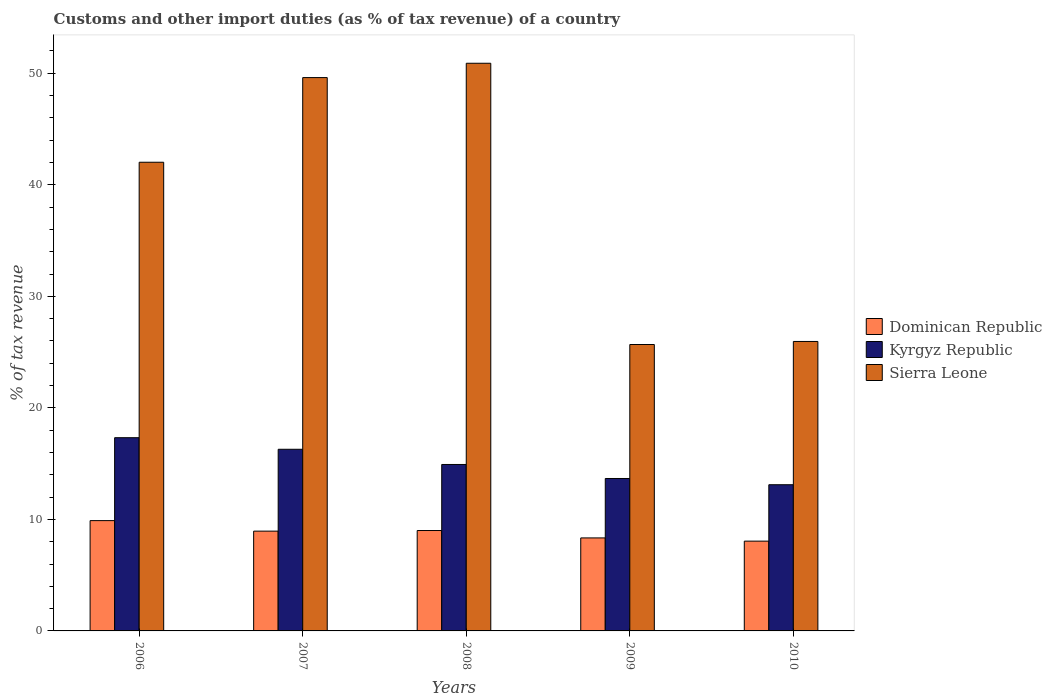How many groups of bars are there?
Make the answer very short. 5. Are the number of bars per tick equal to the number of legend labels?
Give a very brief answer. Yes. Are the number of bars on each tick of the X-axis equal?
Offer a very short reply. Yes. What is the label of the 2nd group of bars from the left?
Ensure brevity in your answer.  2007. What is the percentage of tax revenue from customs in Kyrgyz Republic in 2007?
Offer a terse response. 16.29. Across all years, what is the maximum percentage of tax revenue from customs in Sierra Leone?
Keep it short and to the point. 50.9. Across all years, what is the minimum percentage of tax revenue from customs in Sierra Leone?
Your response must be concise. 25.68. In which year was the percentage of tax revenue from customs in Dominican Republic maximum?
Keep it short and to the point. 2006. In which year was the percentage of tax revenue from customs in Kyrgyz Republic minimum?
Your answer should be very brief. 2010. What is the total percentage of tax revenue from customs in Sierra Leone in the graph?
Provide a short and direct response. 194.17. What is the difference between the percentage of tax revenue from customs in Dominican Republic in 2008 and that in 2009?
Offer a very short reply. 0.66. What is the difference between the percentage of tax revenue from customs in Kyrgyz Republic in 2007 and the percentage of tax revenue from customs in Sierra Leone in 2009?
Provide a succinct answer. -9.39. What is the average percentage of tax revenue from customs in Kyrgyz Republic per year?
Give a very brief answer. 15.06. In the year 2007, what is the difference between the percentage of tax revenue from customs in Kyrgyz Republic and percentage of tax revenue from customs in Dominican Republic?
Provide a short and direct response. 7.34. What is the ratio of the percentage of tax revenue from customs in Sierra Leone in 2007 to that in 2009?
Keep it short and to the point. 1.93. What is the difference between the highest and the second highest percentage of tax revenue from customs in Kyrgyz Republic?
Ensure brevity in your answer.  1.04. What is the difference between the highest and the lowest percentage of tax revenue from customs in Dominican Republic?
Give a very brief answer. 1.84. What does the 3rd bar from the left in 2008 represents?
Offer a very short reply. Sierra Leone. What does the 2nd bar from the right in 2010 represents?
Ensure brevity in your answer.  Kyrgyz Republic. Is it the case that in every year, the sum of the percentage of tax revenue from customs in Dominican Republic and percentage of tax revenue from customs in Kyrgyz Republic is greater than the percentage of tax revenue from customs in Sierra Leone?
Give a very brief answer. No. How many bars are there?
Make the answer very short. 15. Are all the bars in the graph horizontal?
Your answer should be compact. No. What is the difference between two consecutive major ticks on the Y-axis?
Provide a short and direct response. 10. Does the graph contain any zero values?
Offer a terse response. No. Where does the legend appear in the graph?
Your answer should be compact. Center right. How are the legend labels stacked?
Keep it short and to the point. Vertical. What is the title of the graph?
Provide a short and direct response. Customs and other import duties (as % of tax revenue) of a country. Does "High income" appear as one of the legend labels in the graph?
Your answer should be very brief. No. What is the label or title of the X-axis?
Ensure brevity in your answer.  Years. What is the label or title of the Y-axis?
Provide a succinct answer. % of tax revenue. What is the % of tax revenue in Dominican Republic in 2006?
Give a very brief answer. 9.89. What is the % of tax revenue in Kyrgyz Republic in 2006?
Provide a short and direct response. 17.32. What is the % of tax revenue of Sierra Leone in 2006?
Your answer should be very brief. 42.02. What is the % of tax revenue of Dominican Republic in 2007?
Provide a short and direct response. 8.95. What is the % of tax revenue of Kyrgyz Republic in 2007?
Give a very brief answer. 16.29. What is the % of tax revenue in Sierra Leone in 2007?
Offer a terse response. 49.61. What is the % of tax revenue of Dominican Republic in 2008?
Offer a very short reply. 9. What is the % of tax revenue in Kyrgyz Republic in 2008?
Provide a short and direct response. 14.92. What is the % of tax revenue in Sierra Leone in 2008?
Your response must be concise. 50.9. What is the % of tax revenue in Dominican Republic in 2009?
Offer a very short reply. 8.34. What is the % of tax revenue in Kyrgyz Republic in 2009?
Provide a succinct answer. 13.67. What is the % of tax revenue in Sierra Leone in 2009?
Ensure brevity in your answer.  25.68. What is the % of tax revenue in Dominican Republic in 2010?
Give a very brief answer. 8.05. What is the % of tax revenue in Kyrgyz Republic in 2010?
Provide a short and direct response. 13.11. What is the % of tax revenue in Sierra Leone in 2010?
Give a very brief answer. 25.95. Across all years, what is the maximum % of tax revenue in Dominican Republic?
Make the answer very short. 9.89. Across all years, what is the maximum % of tax revenue in Kyrgyz Republic?
Offer a very short reply. 17.32. Across all years, what is the maximum % of tax revenue in Sierra Leone?
Offer a very short reply. 50.9. Across all years, what is the minimum % of tax revenue of Dominican Republic?
Ensure brevity in your answer.  8.05. Across all years, what is the minimum % of tax revenue in Kyrgyz Republic?
Offer a very short reply. 13.11. Across all years, what is the minimum % of tax revenue in Sierra Leone?
Ensure brevity in your answer.  25.68. What is the total % of tax revenue in Dominican Republic in the graph?
Give a very brief answer. 44.23. What is the total % of tax revenue in Kyrgyz Republic in the graph?
Ensure brevity in your answer.  75.31. What is the total % of tax revenue of Sierra Leone in the graph?
Keep it short and to the point. 194.17. What is the difference between the % of tax revenue in Dominican Republic in 2006 and that in 2007?
Make the answer very short. 0.94. What is the difference between the % of tax revenue in Kyrgyz Republic in 2006 and that in 2007?
Keep it short and to the point. 1.04. What is the difference between the % of tax revenue of Sierra Leone in 2006 and that in 2007?
Your answer should be very brief. -7.59. What is the difference between the % of tax revenue of Dominican Republic in 2006 and that in 2008?
Your response must be concise. 0.89. What is the difference between the % of tax revenue of Kyrgyz Republic in 2006 and that in 2008?
Offer a terse response. 2.4. What is the difference between the % of tax revenue of Sierra Leone in 2006 and that in 2008?
Make the answer very short. -8.87. What is the difference between the % of tax revenue in Dominican Republic in 2006 and that in 2009?
Ensure brevity in your answer.  1.55. What is the difference between the % of tax revenue in Kyrgyz Republic in 2006 and that in 2009?
Provide a short and direct response. 3.66. What is the difference between the % of tax revenue in Sierra Leone in 2006 and that in 2009?
Keep it short and to the point. 16.34. What is the difference between the % of tax revenue of Dominican Republic in 2006 and that in 2010?
Offer a very short reply. 1.84. What is the difference between the % of tax revenue of Kyrgyz Republic in 2006 and that in 2010?
Give a very brief answer. 4.22. What is the difference between the % of tax revenue of Sierra Leone in 2006 and that in 2010?
Provide a short and direct response. 16.07. What is the difference between the % of tax revenue of Dominican Republic in 2007 and that in 2008?
Make the answer very short. -0.05. What is the difference between the % of tax revenue in Kyrgyz Republic in 2007 and that in 2008?
Offer a very short reply. 1.36. What is the difference between the % of tax revenue in Sierra Leone in 2007 and that in 2008?
Keep it short and to the point. -1.28. What is the difference between the % of tax revenue of Dominican Republic in 2007 and that in 2009?
Keep it short and to the point. 0.61. What is the difference between the % of tax revenue in Kyrgyz Republic in 2007 and that in 2009?
Provide a succinct answer. 2.62. What is the difference between the % of tax revenue in Sierra Leone in 2007 and that in 2009?
Provide a short and direct response. 23.93. What is the difference between the % of tax revenue in Dominican Republic in 2007 and that in 2010?
Give a very brief answer. 0.9. What is the difference between the % of tax revenue of Kyrgyz Republic in 2007 and that in 2010?
Make the answer very short. 3.18. What is the difference between the % of tax revenue in Sierra Leone in 2007 and that in 2010?
Make the answer very short. 23.66. What is the difference between the % of tax revenue of Dominican Republic in 2008 and that in 2009?
Make the answer very short. 0.66. What is the difference between the % of tax revenue of Kyrgyz Republic in 2008 and that in 2009?
Your answer should be very brief. 1.26. What is the difference between the % of tax revenue in Sierra Leone in 2008 and that in 2009?
Provide a succinct answer. 25.22. What is the difference between the % of tax revenue of Dominican Republic in 2008 and that in 2010?
Ensure brevity in your answer.  0.95. What is the difference between the % of tax revenue in Kyrgyz Republic in 2008 and that in 2010?
Make the answer very short. 1.82. What is the difference between the % of tax revenue of Sierra Leone in 2008 and that in 2010?
Give a very brief answer. 24.94. What is the difference between the % of tax revenue of Dominican Republic in 2009 and that in 2010?
Offer a terse response. 0.29. What is the difference between the % of tax revenue in Kyrgyz Republic in 2009 and that in 2010?
Keep it short and to the point. 0.56. What is the difference between the % of tax revenue in Sierra Leone in 2009 and that in 2010?
Make the answer very short. -0.27. What is the difference between the % of tax revenue in Dominican Republic in 2006 and the % of tax revenue in Kyrgyz Republic in 2007?
Provide a short and direct response. -6.4. What is the difference between the % of tax revenue of Dominican Republic in 2006 and the % of tax revenue of Sierra Leone in 2007?
Your answer should be compact. -39.72. What is the difference between the % of tax revenue of Kyrgyz Republic in 2006 and the % of tax revenue of Sierra Leone in 2007?
Ensure brevity in your answer.  -32.29. What is the difference between the % of tax revenue of Dominican Republic in 2006 and the % of tax revenue of Kyrgyz Republic in 2008?
Provide a short and direct response. -5.03. What is the difference between the % of tax revenue in Dominican Republic in 2006 and the % of tax revenue in Sierra Leone in 2008?
Offer a terse response. -41.01. What is the difference between the % of tax revenue of Kyrgyz Republic in 2006 and the % of tax revenue of Sierra Leone in 2008?
Provide a succinct answer. -33.57. What is the difference between the % of tax revenue in Dominican Republic in 2006 and the % of tax revenue in Kyrgyz Republic in 2009?
Offer a very short reply. -3.78. What is the difference between the % of tax revenue of Dominican Republic in 2006 and the % of tax revenue of Sierra Leone in 2009?
Make the answer very short. -15.79. What is the difference between the % of tax revenue in Kyrgyz Republic in 2006 and the % of tax revenue in Sierra Leone in 2009?
Your answer should be very brief. -8.36. What is the difference between the % of tax revenue in Dominican Republic in 2006 and the % of tax revenue in Kyrgyz Republic in 2010?
Ensure brevity in your answer.  -3.22. What is the difference between the % of tax revenue of Dominican Republic in 2006 and the % of tax revenue of Sierra Leone in 2010?
Your response must be concise. -16.06. What is the difference between the % of tax revenue of Kyrgyz Republic in 2006 and the % of tax revenue of Sierra Leone in 2010?
Make the answer very short. -8.63. What is the difference between the % of tax revenue in Dominican Republic in 2007 and the % of tax revenue in Kyrgyz Republic in 2008?
Make the answer very short. -5.98. What is the difference between the % of tax revenue in Dominican Republic in 2007 and the % of tax revenue in Sierra Leone in 2008?
Provide a succinct answer. -41.95. What is the difference between the % of tax revenue in Kyrgyz Republic in 2007 and the % of tax revenue in Sierra Leone in 2008?
Provide a short and direct response. -34.61. What is the difference between the % of tax revenue of Dominican Republic in 2007 and the % of tax revenue of Kyrgyz Republic in 2009?
Your answer should be very brief. -4.72. What is the difference between the % of tax revenue of Dominican Republic in 2007 and the % of tax revenue of Sierra Leone in 2009?
Keep it short and to the point. -16.73. What is the difference between the % of tax revenue of Kyrgyz Republic in 2007 and the % of tax revenue of Sierra Leone in 2009?
Your answer should be very brief. -9.39. What is the difference between the % of tax revenue of Dominican Republic in 2007 and the % of tax revenue of Kyrgyz Republic in 2010?
Offer a terse response. -4.16. What is the difference between the % of tax revenue of Dominican Republic in 2007 and the % of tax revenue of Sierra Leone in 2010?
Provide a succinct answer. -17.01. What is the difference between the % of tax revenue of Kyrgyz Republic in 2007 and the % of tax revenue of Sierra Leone in 2010?
Make the answer very short. -9.67. What is the difference between the % of tax revenue in Dominican Republic in 2008 and the % of tax revenue in Kyrgyz Republic in 2009?
Make the answer very short. -4.67. What is the difference between the % of tax revenue in Dominican Republic in 2008 and the % of tax revenue in Sierra Leone in 2009?
Your answer should be compact. -16.68. What is the difference between the % of tax revenue in Kyrgyz Republic in 2008 and the % of tax revenue in Sierra Leone in 2009?
Provide a short and direct response. -10.76. What is the difference between the % of tax revenue of Dominican Republic in 2008 and the % of tax revenue of Kyrgyz Republic in 2010?
Provide a short and direct response. -4.11. What is the difference between the % of tax revenue in Dominican Republic in 2008 and the % of tax revenue in Sierra Leone in 2010?
Your response must be concise. -16.95. What is the difference between the % of tax revenue of Kyrgyz Republic in 2008 and the % of tax revenue of Sierra Leone in 2010?
Provide a short and direct response. -11.03. What is the difference between the % of tax revenue of Dominican Republic in 2009 and the % of tax revenue of Kyrgyz Republic in 2010?
Offer a very short reply. -4.77. What is the difference between the % of tax revenue of Dominican Republic in 2009 and the % of tax revenue of Sierra Leone in 2010?
Offer a very short reply. -17.62. What is the difference between the % of tax revenue in Kyrgyz Republic in 2009 and the % of tax revenue in Sierra Leone in 2010?
Your response must be concise. -12.29. What is the average % of tax revenue of Dominican Republic per year?
Your answer should be compact. 8.85. What is the average % of tax revenue in Kyrgyz Republic per year?
Keep it short and to the point. 15.06. What is the average % of tax revenue in Sierra Leone per year?
Your response must be concise. 38.83. In the year 2006, what is the difference between the % of tax revenue in Dominican Republic and % of tax revenue in Kyrgyz Republic?
Your answer should be very brief. -7.43. In the year 2006, what is the difference between the % of tax revenue of Dominican Republic and % of tax revenue of Sierra Leone?
Make the answer very short. -32.13. In the year 2006, what is the difference between the % of tax revenue in Kyrgyz Republic and % of tax revenue in Sierra Leone?
Provide a short and direct response. -24.7. In the year 2007, what is the difference between the % of tax revenue in Dominican Republic and % of tax revenue in Kyrgyz Republic?
Your answer should be very brief. -7.34. In the year 2007, what is the difference between the % of tax revenue in Dominican Republic and % of tax revenue in Sierra Leone?
Provide a short and direct response. -40.67. In the year 2007, what is the difference between the % of tax revenue in Kyrgyz Republic and % of tax revenue in Sierra Leone?
Your response must be concise. -33.33. In the year 2008, what is the difference between the % of tax revenue of Dominican Republic and % of tax revenue of Kyrgyz Republic?
Offer a very short reply. -5.92. In the year 2008, what is the difference between the % of tax revenue of Dominican Republic and % of tax revenue of Sierra Leone?
Make the answer very short. -41.9. In the year 2008, what is the difference between the % of tax revenue of Kyrgyz Republic and % of tax revenue of Sierra Leone?
Give a very brief answer. -35.97. In the year 2009, what is the difference between the % of tax revenue in Dominican Republic and % of tax revenue in Kyrgyz Republic?
Provide a short and direct response. -5.33. In the year 2009, what is the difference between the % of tax revenue of Dominican Republic and % of tax revenue of Sierra Leone?
Your answer should be very brief. -17.34. In the year 2009, what is the difference between the % of tax revenue in Kyrgyz Republic and % of tax revenue in Sierra Leone?
Ensure brevity in your answer.  -12.01. In the year 2010, what is the difference between the % of tax revenue of Dominican Republic and % of tax revenue of Kyrgyz Republic?
Keep it short and to the point. -5.06. In the year 2010, what is the difference between the % of tax revenue of Dominican Republic and % of tax revenue of Sierra Leone?
Make the answer very short. -17.9. In the year 2010, what is the difference between the % of tax revenue of Kyrgyz Republic and % of tax revenue of Sierra Leone?
Your answer should be compact. -12.85. What is the ratio of the % of tax revenue of Dominican Republic in 2006 to that in 2007?
Your response must be concise. 1.11. What is the ratio of the % of tax revenue of Kyrgyz Republic in 2006 to that in 2007?
Your response must be concise. 1.06. What is the ratio of the % of tax revenue in Sierra Leone in 2006 to that in 2007?
Make the answer very short. 0.85. What is the ratio of the % of tax revenue of Dominican Republic in 2006 to that in 2008?
Ensure brevity in your answer.  1.1. What is the ratio of the % of tax revenue of Kyrgyz Republic in 2006 to that in 2008?
Make the answer very short. 1.16. What is the ratio of the % of tax revenue of Sierra Leone in 2006 to that in 2008?
Offer a very short reply. 0.83. What is the ratio of the % of tax revenue of Dominican Republic in 2006 to that in 2009?
Your answer should be very brief. 1.19. What is the ratio of the % of tax revenue of Kyrgyz Republic in 2006 to that in 2009?
Provide a succinct answer. 1.27. What is the ratio of the % of tax revenue of Sierra Leone in 2006 to that in 2009?
Your answer should be compact. 1.64. What is the ratio of the % of tax revenue of Dominican Republic in 2006 to that in 2010?
Keep it short and to the point. 1.23. What is the ratio of the % of tax revenue of Kyrgyz Republic in 2006 to that in 2010?
Give a very brief answer. 1.32. What is the ratio of the % of tax revenue in Sierra Leone in 2006 to that in 2010?
Give a very brief answer. 1.62. What is the ratio of the % of tax revenue in Kyrgyz Republic in 2007 to that in 2008?
Ensure brevity in your answer.  1.09. What is the ratio of the % of tax revenue in Sierra Leone in 2007 to that in 2008?
Make the answer very short. 0.97. What is the ratio of the % of tax revenue of Dominican Republic in 2007 to that in 2009?
Ensure brevity in your answer.  1.07. What is the ratio of the % of tax revenue in Kyrgyz Republic in 2007 to that in 2009?
Offer a very short reply. 1.19. What is the ratio of the % of tax revenue of Sierra Leone in 2007 to that in 2009?
Provide a succinct answer. 1.93. What is the ratio of the % of tax revenue in Dominican Republic in 2007 to that in 2010?
Ensure brevity in your answer.  1.11. What is the ratio of the % of tax revenue of Kyrgyz Republic in 2007 to that in 2010?
Offer a very short reply. 1.24. What is the ratio of the % of tax revenue in Sierra Leone in 2007 to that in 2010?
Offer a terse response. 1.91. What is the ratio of the % of tax revenue in Dominican Republic in 2008 to that in 2009?
Ensure brevity in your answer.  1.08. What is the ratio of the % of tax revenue in Kyrgyz Republic in 2008 to that in 2009?
Make the answer very short. 1.09. What is the ratio of the % of tax revenue of Sierra Leone in 2008 to that in 2009?
Provide a succinct answer. 1.98. What is the ratio of the % of tax revenue of Dominican Republic in 2008 to that in 2010?
Make the answer very short. 1.12. What is the ratio of the % of tax revenue in Kyrgyz Republic in 2008 to that in 2010?
Your answer should be very brief. 1.14. What is the ratio of the % of tax revenue in Sierra Leone in 2008 to that in 2010?
Your answer should be very brief. 1.96. What is the ratio of the % of tax revenue in Dominican Republic in 2009 to that in 2010?
Provide a short and direct response. 1.04. What is the ratio of the % of tax revenue of Kyrgyz Republic in 2009 to that in 2010?
Offer a terse response. 1.04. What is the ratio of the % of tax revenue in Sierra Leone in 2009 to that in 2010?
Give a very brief answer. 0.99. What is the difference between the highest and the second highest % of tax revenue of Dominican Republic?
Your response must be concise. 0.89. What is the difference between the highest and the second highest % of tax revenue in Kyrgyz Republic?
Offer a terse response. 1.04. What is the difference between the highest and the second highest % of tax revenue in Sierra Leone?
Provide a succinct answer. 1.28. What is the difference between the highest and the lowest % of tax revenue of Dominican Republic?
Provide a short and direct response. 1.84. What is the difference between the highest and the lowest % of tax revenue of Kyrgyz Republic?
Ensure brevity in your answer.  4.22. What is the difference between the highest and the lowest % of tax revenue in Sierra Leone?
Offer a terse response. 25.22. 